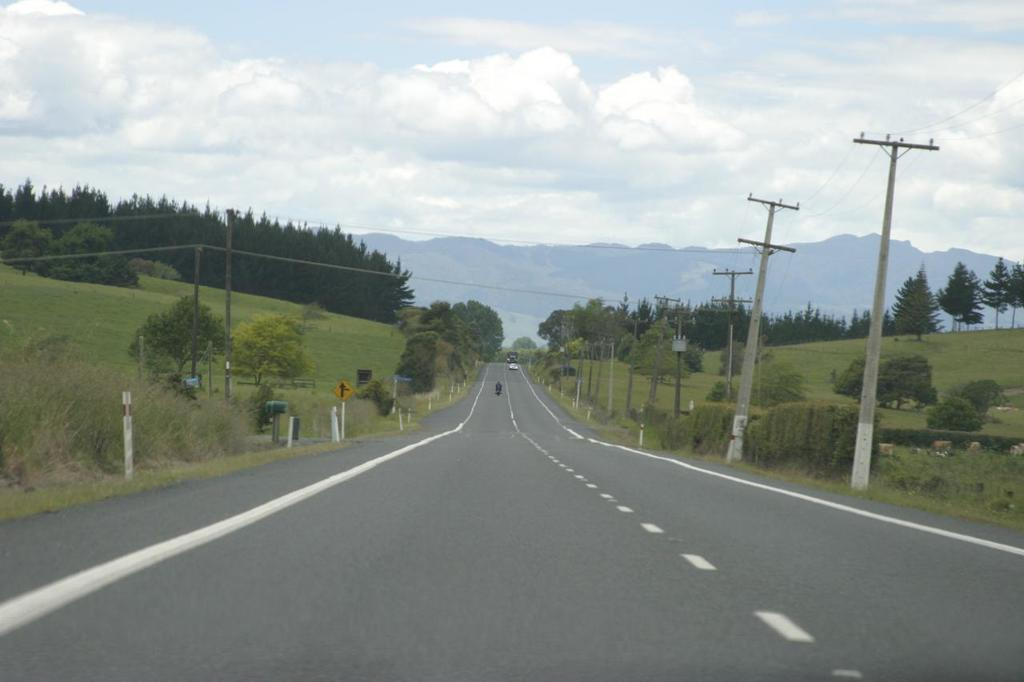What is the main feature in the center of the image? There is a road in the center of the image. What is happening on the road? Vehicles are present on the road. What can be seen attached to the poles in the image? Wires are visible in the image. What type of natural features can be seen in the background of the image? There are trees and hills in the background of the image. What is visible above the trees and hills in the image? The sky is visible in the background of the image. Where is the nearest hospital to the location shown in the image? There is no information about the location or the nearest hospital in the image. What type of button can be seen on the vehicles in the image? There are no buttons visible on the vehicles in the image. 